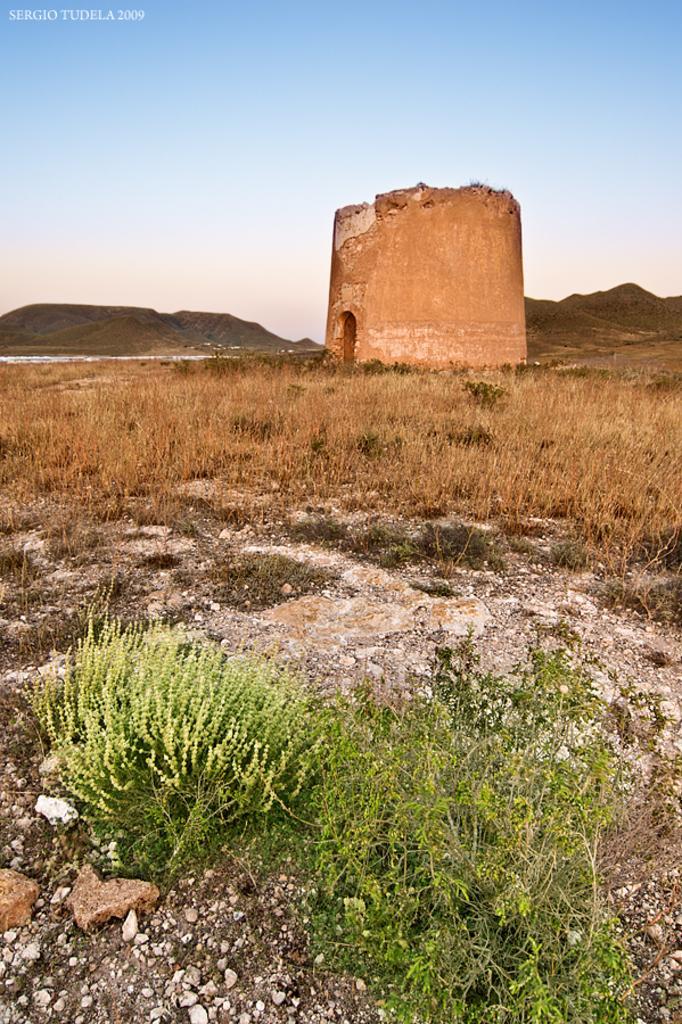In one or two sentences, can you explain what this image depicts? We can see plants and dried grass. In the background we can see wall,hills and sky. In the top left of the image we can see watermark. 